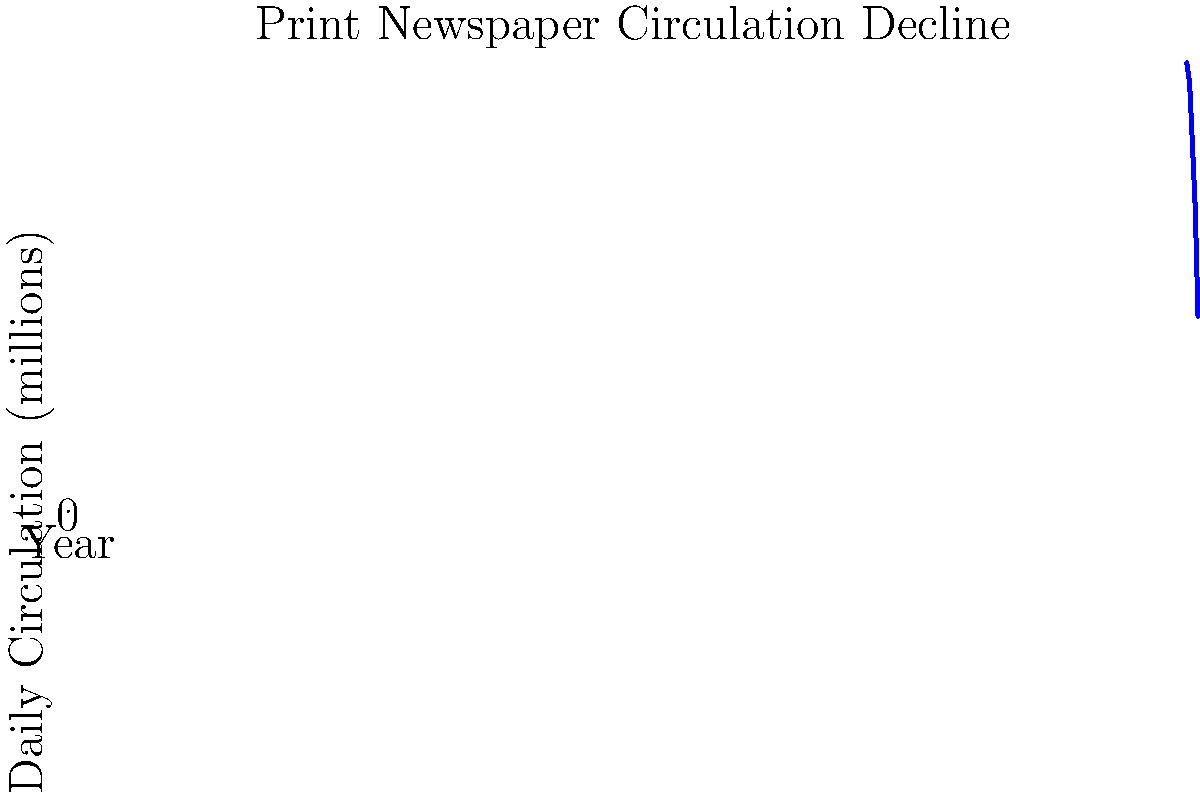Analyzing the graph, what was the approximate percentage decrease in daily print newspaper circulation between 2000 and 2020? How might this trend relate to the changing landscape of media consumption and the ethical responsibilities of journalists in the digital age? To calculate the percentage decrease in daily print newspaper circulation between 2000 and 2020:

1. Identify the circulation values:
   2000: 55.8 million
   2020: 24.3 million

2. Calculate the difference:
   55.8 - 24.3 = 31.5 million

3. Calculate the percentage decrease:
   (31.5 / 55.8) * 100 ≈ 56.45%

The percentage decrease is approximately 56.45%.

This trend reflects the significant shift in media consumption habits over the past two decades. The rise of digital platforms and online news sources has led to a decline in traditional print newspaper readership. This change raises important questions about the ethical responsibilities of journalists in the digital age:

1. Adapting to new platforms while maintaining journalistic integrity
2. Balancing the need for timely reporting with fact-checking and accuracy
3. Addressing the issue of "fake news" and misinformation in online spaces
4. Ensuring diverse voices and perspectives are represented in digital media
5. Navigating the challenges of social media and its impact on news dissemination

As a journalism major, considering these ethical implications is crucial when examining the evolving media landscape and its effects on public information consumption.
Answer: 56.45% decrease; raises questions about journalistic ethics in digital age 